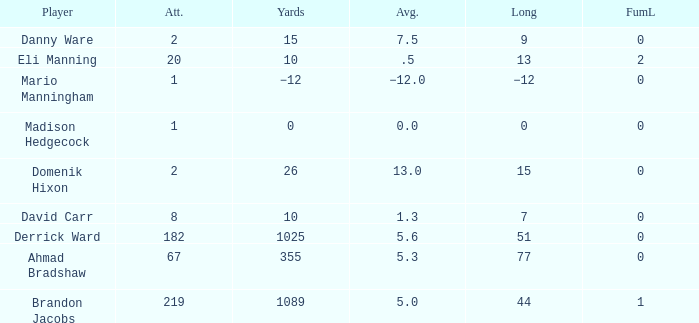What is the average rushing distance for domenik hixon? 13.0. 